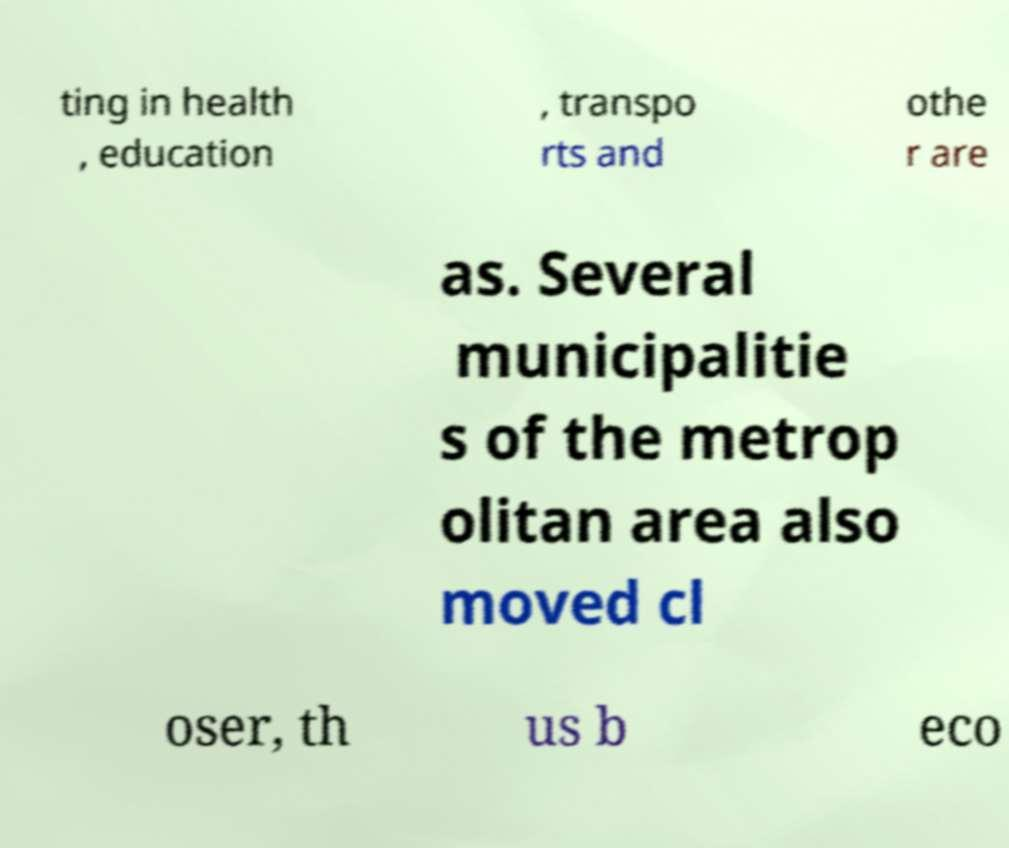There's text embedded in this image that I need extracted. Can you transcribe it verbatim? ting in health , education , transpo rts and othe r are as. Several municipalitie s of the metrop olitan area also moved cl oser, th us b eco 